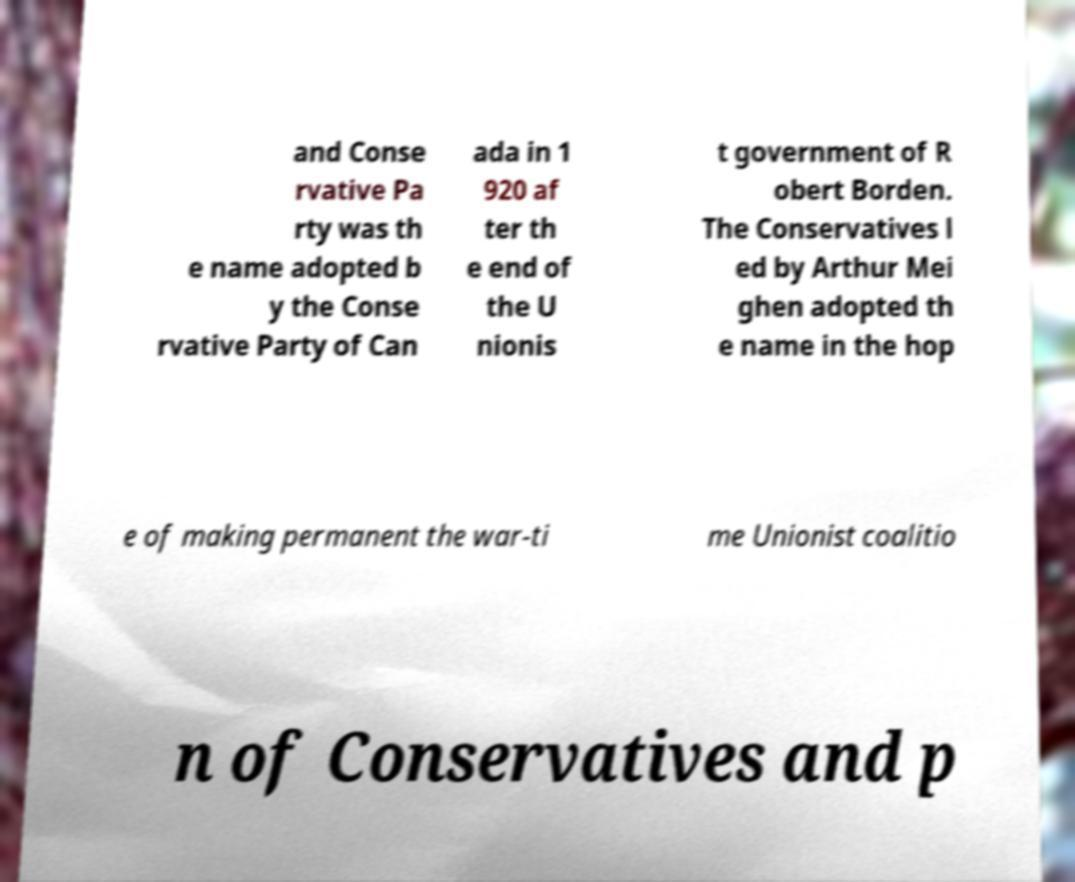For documentation purposes, I need the text within this image transcribed. Could you provide that? and Conse rvative Pa rty was th e name adopted b y the Conse rvative Party of Can ada in 1 920 af ter th e end of the U nionis t government of R obert Borden. The Conservatives l ed by Arthur Mei ghen adopted th e name in the hop e of making permanent the war-ti me Unionist coalitio n of Conservatives and p 